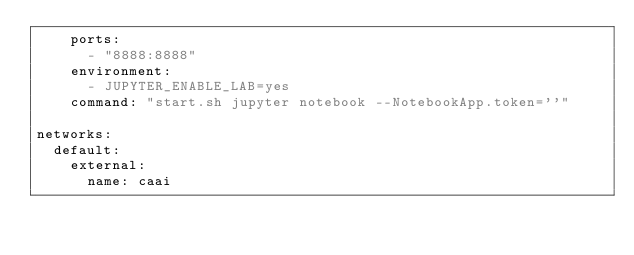<code> <loc_0><loc_0><loc_500><loc_500><_YAML_>    ports:
      - "8888:8888"
    environment:
      - JUPYTER_ENABLE_LAB=yes
    command: "start.sh jupyter notebook --NotebookApp.token=''"
    
networks:
  default:
    external:
      name: caai
</code> 